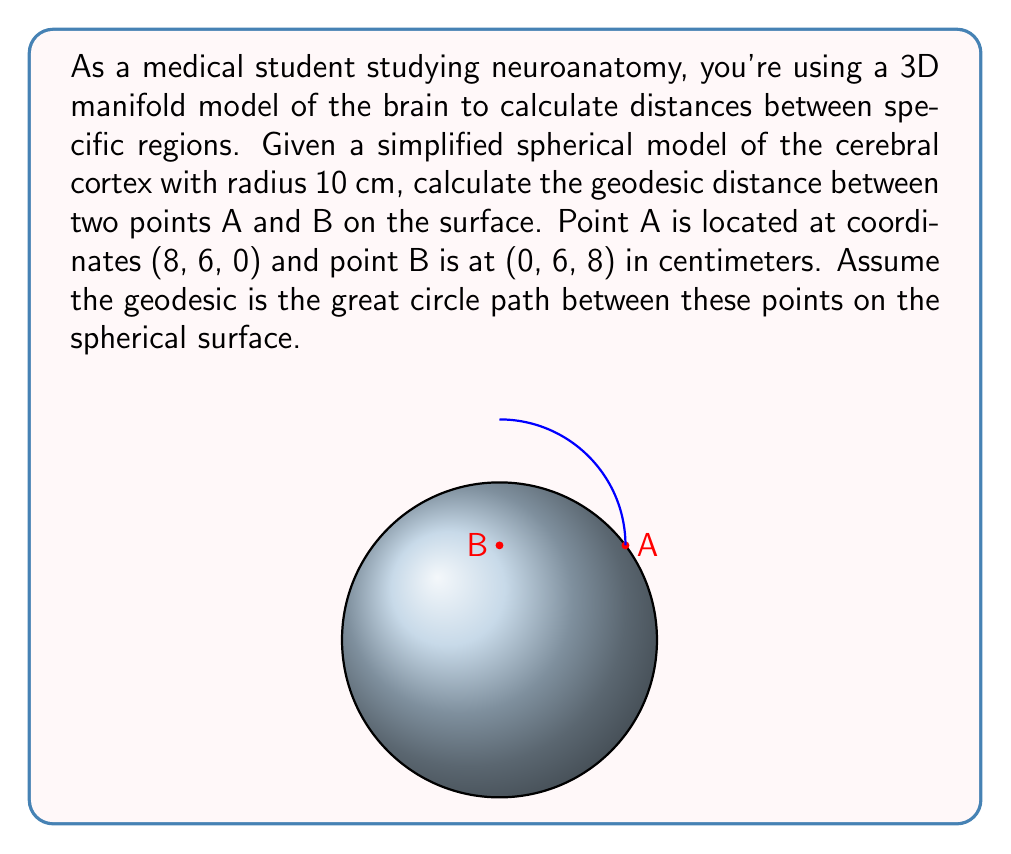Can you solve this math problem? To solve this problem, we'll follow these steps:

1) First, we need to find the angle θ between the two position vectors OA and OB. We can do this using the dot product formula:

   $$\cos \theta = \frac{\vec{OA} \cdot \vec{OB}}{|\vec{OA}||\vec{OB}|}$$

2) Calculate the dot product:
   $$\vec{OA} \cdot \vec{OB} = 8(0) + 6(6) + 0(8) = 36$$

3) Calculate the magnitudes:
   $$|\vec{OA}| = |\vec{OB}| = \sqrt{8^2 + 6^2 + 0^2} = \sqrt{8^2 + 6^2 + 8^2} = 10$$

4) Substitute into the formula:
   $$\cos \theta = \frac{36}{10 \cdot 10} = \frac{36}{100} = 0.36$$

5) Take the inverse cosine (arccos) to find θ:
   $$\theta = \arccos(0.36) \approx 1.2090 \text{ radians}$$

6) The geodesic distance is the arc length, which is given by the formula:
   $$s = r\theta$$
   where r is the radius of the sphere (10 cm in this case).

7) Calculate the geodesic distance:
   $$s = 10 \cdot 1.2090 \approx 12.090 \text{ cm}$$
Answer: $12.090 \text{ cm}$ 